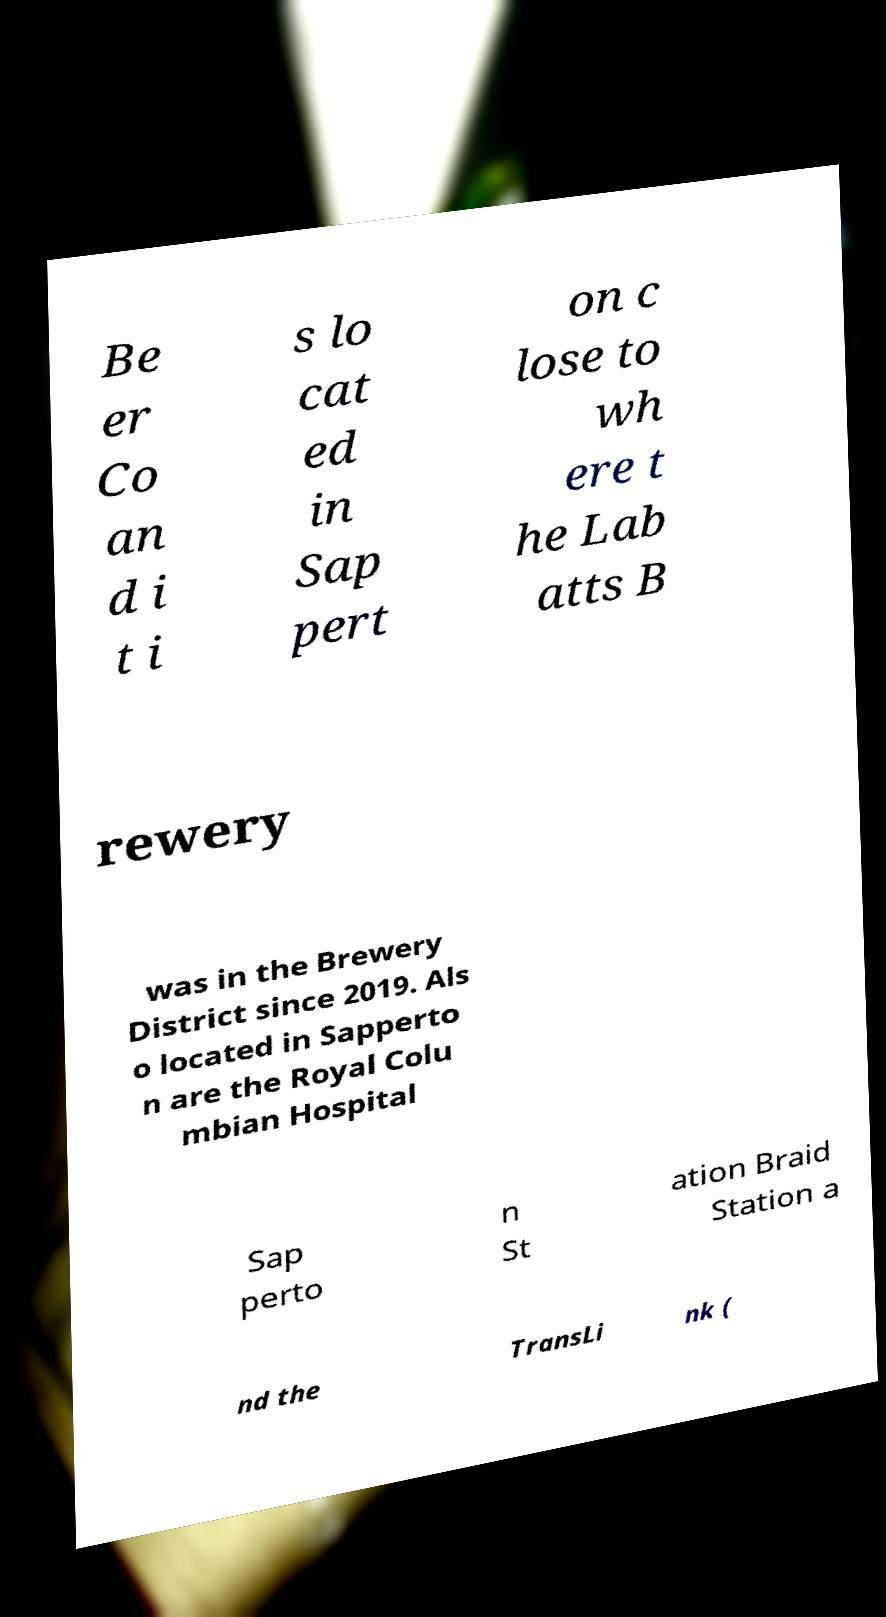There's text embedded in this image that I need extracted. Can you transcribe it verbatim? Be er Co an d i t i s lo cat ed in Sap pert on c lose to wh ere t he Lab atts B rewery was in the Brewery District since 2019. Als o located in Sapperto n are the Royal Colu mbian Hospital Sap perto n St ation Braid Station a nd the TransLi nk ( 